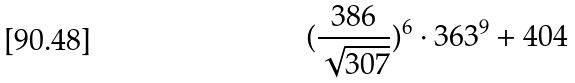Convert formula to latex. <formula><loc_0><loc_0><loc_500><loc_500>( \frac { 3 8 6 } { \sqrt { 3 0 7 } } ) ^ { 6 } \cdot 3 6 3 ^ { 9 } + 4 0 4</formula> 